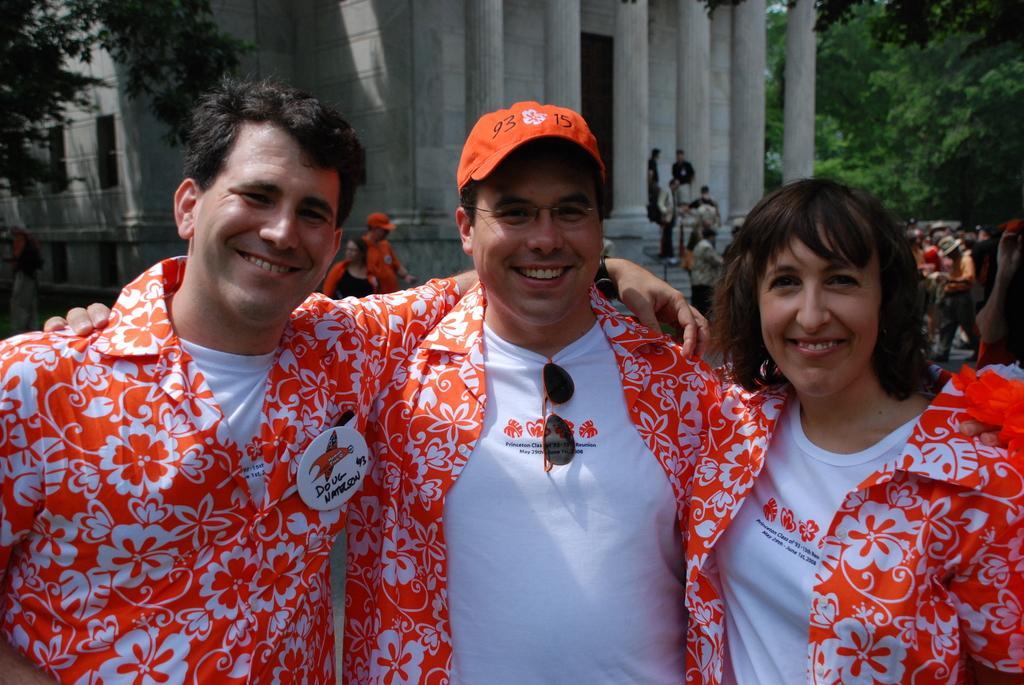In one or two sentences, can you explain what this image depicts? In this image in the foreground we can see three people standing. In the background, we can see the buildings, trees and pillars. And we can see some other people. 